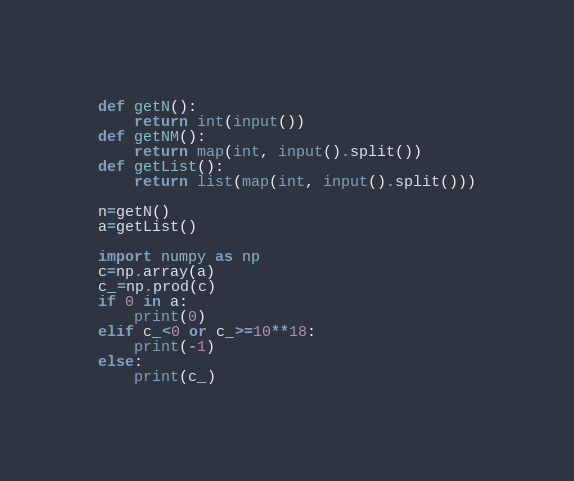Convert code to text. <code><loc_0><loc_0><loc_500><loc_500><_Python_>def getN():
    return int(input())
def getNM():
    return map(int, input().split())
def getList():
    return list(map(int, input().split()))

n=getN()
a=getList()

import numpy as np
c=np.array(a)
c_=np.prod(c)
if 0 in a:
    print(0)
elif c_<0 or c_>=10**18:
    print(-1)
else:
    print(c_)</code> 